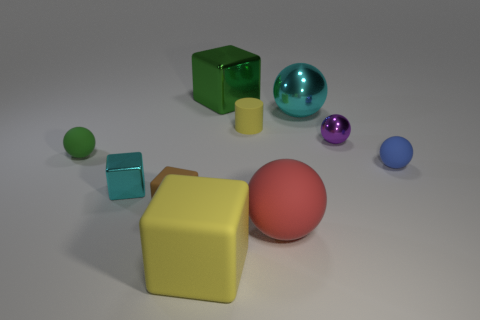Are there any other things that have the same shape as the small yellow thing?
Keep it short and to the point. No. Is the material of the block behind the blue matte ball the same as the small green sphere behind the red sphere?
Keep it short and to the point. No. There is a big cube that is the same color as the cylinder; what material is it?
Offer a terse response. Rubber. The small matte object that is left of the yellow cylinder and behind the small cyan block has what shape?
Your response must be concise. Sphere. What is the material of the object behind the shiny sphere behind the cylinder?
Offer a very short reply. Metal. Are there more small red rubber blocks than shiny balls?
Provide a short and direct response. No. Is the large metal block the same color as the big rubber cube?
Your answer should be compact. No. What material is the cyan sphere that is the same size as the yellow rubber cube?
Provide a succinct answer. Metal. Is the small blue thing made of the same material as the tiny brown thing?
Provide a succinct answer. Yes. What number of tiny green things are made of the same material as the green ball?
Your response must be concise. 0. 